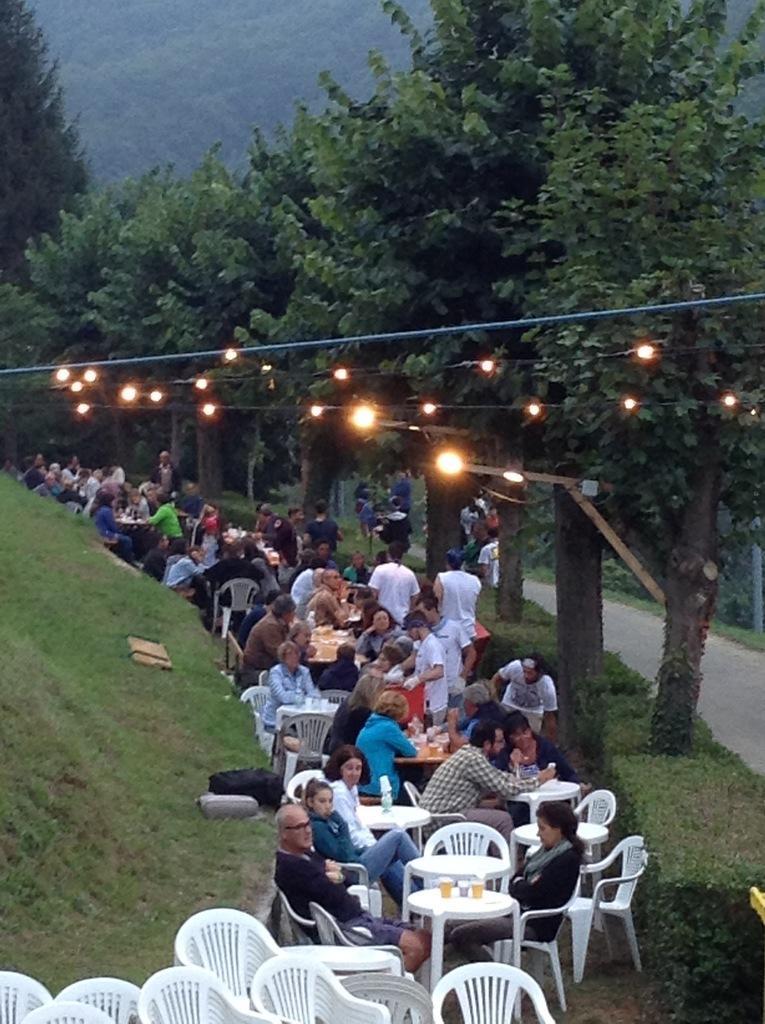Describe this image in one or two sentences. This picture is clicked outside the city where the persons are sitting on a chair and standing. In the front there are empty chairs. In the center there is a table on the table there are glasses. In the background there are trees. At the left side on the floor there is a grass. On the trees there are lights and the persons are sitting and walking. 